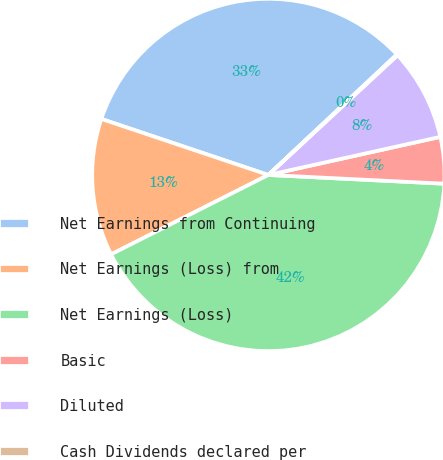Convert chart to OTSL. <chart><loc_0><loc_0><loc_500><loc_500><pie_chart><fcel>Net Earnings from Continuing<fcel>Net Earnings (Loss) from<fcel>Net Earnings (Loss)<fcel>Basic<fcel>Diluted<fcel>Cash Dividends declared per<nl><fcel>32.86%<fcel>12.59%<fcel>41.77%<fcel>4.26%<fcel>8.43%<fcel>0.09%<nl></chart> 